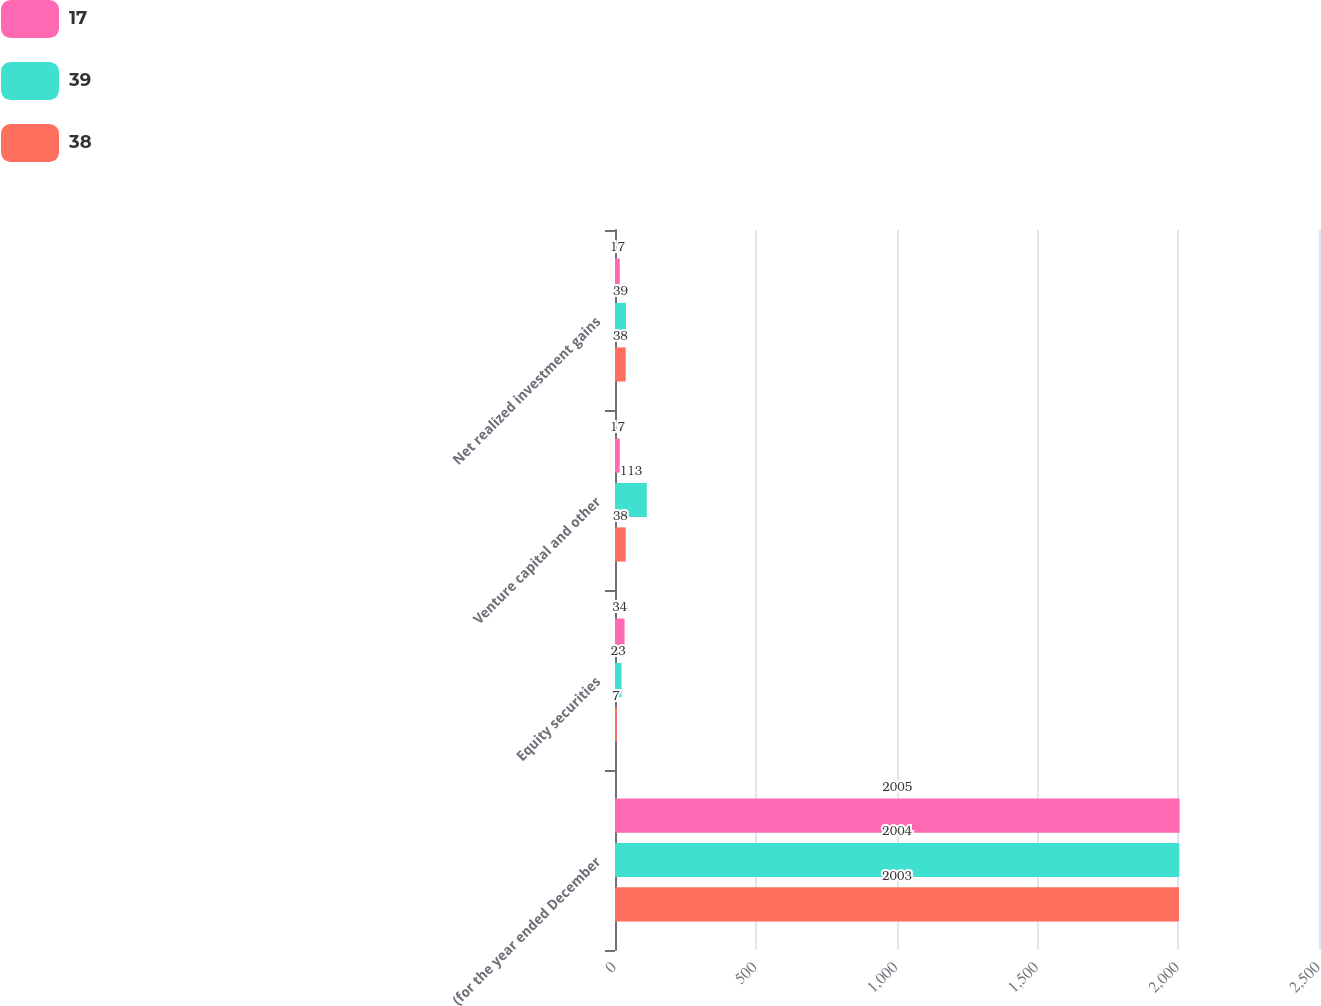Convert chart. <chart><loc_0><loc_0><loc_500><loc_500><stacked_bar_chart><ecel><fcel>(for the year ended December<fcel>Equity securities<fcel>Venture capital and other<fcel>Net realized investment gains<nl><fcel>17<fcel>2005<fcel>34<fcel>17<fcel>17<nl><fcel>39<fcel>2004<fcel>23<fcel>113<fcel>39<nl><fcel>38<fcel>2003<fcel>7<fcel>38<fcel>38<nl></chart> 